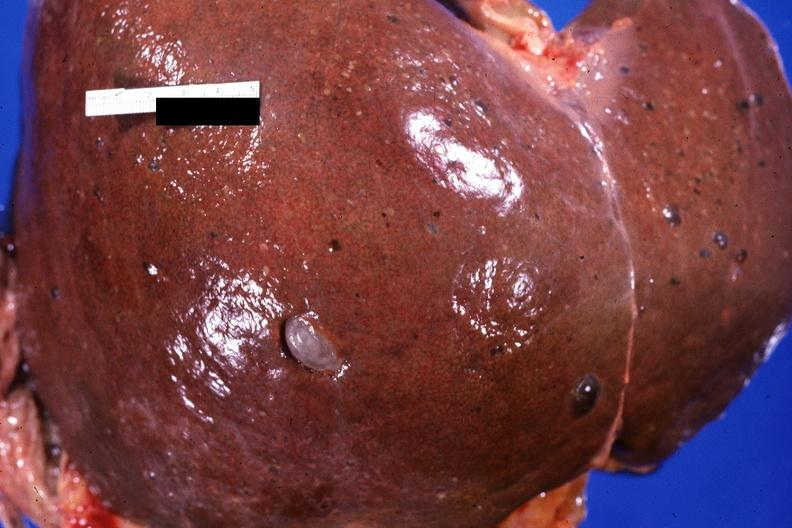s hepatobiliary present?
Answer the question using a single word or phrase. Yes 